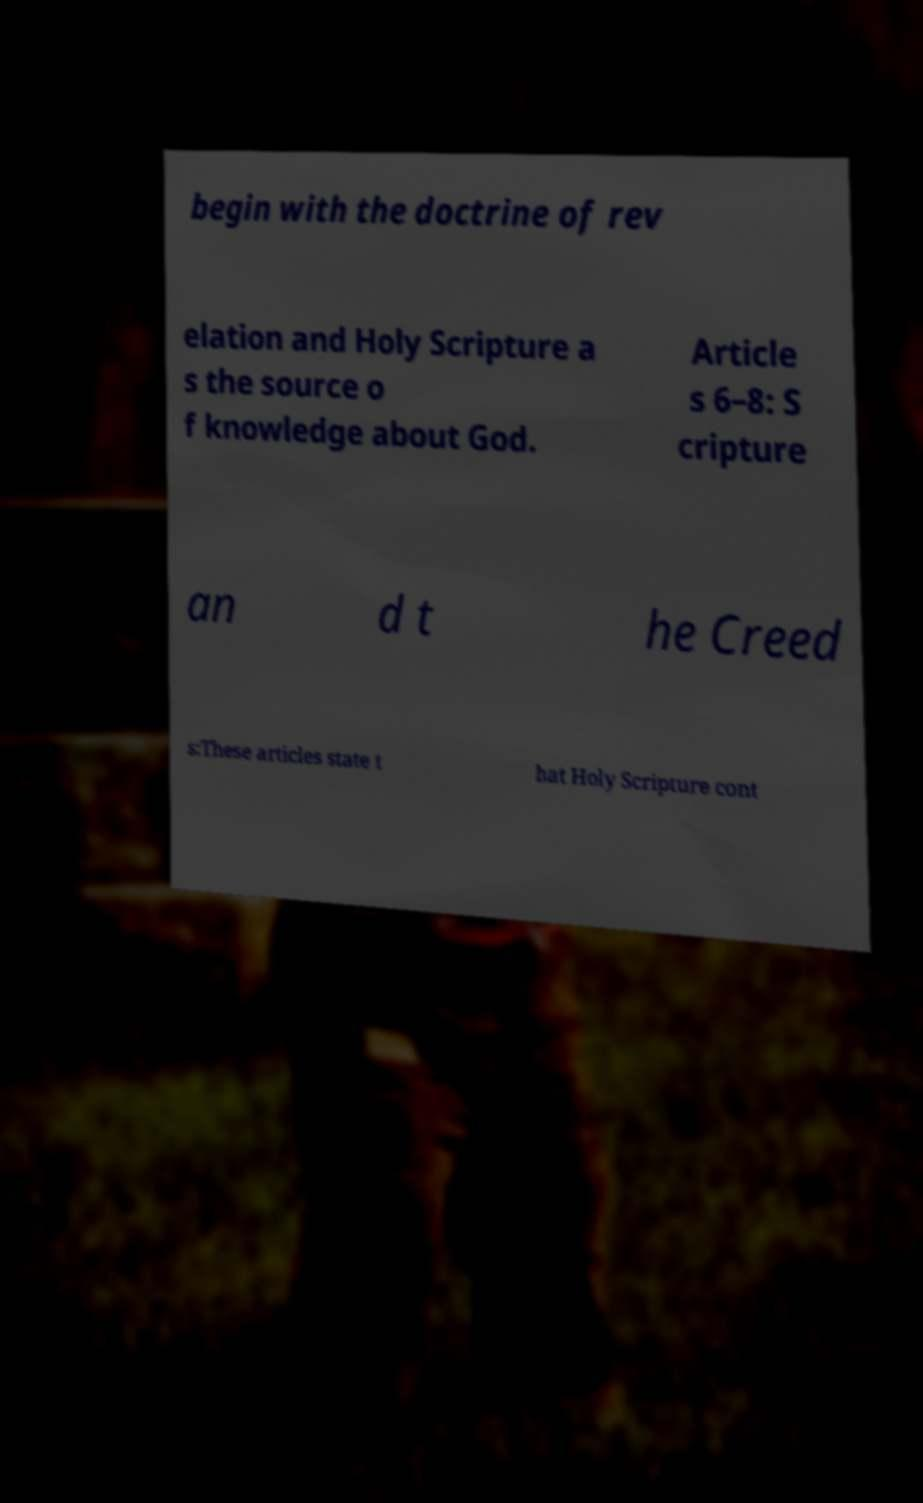What messages or text are displayed in this image? I need them in a readable, typed format. begin with the doctrine of rev elation and Holy Scripture a s the source o f knowledge about God. Article s 6–8: S cripture an d t he Creed s:These articles state t hat Holy Scripture cont 